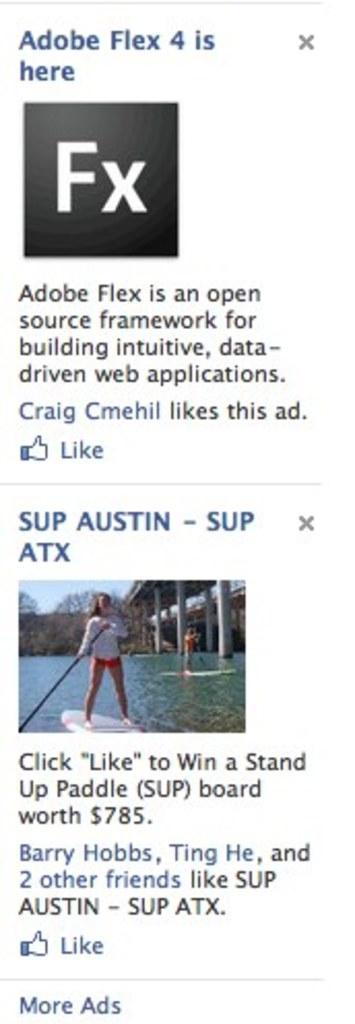How would you summarize this image in a sentence or two? In this image I can see a logo, text and a woman is boating in the water. In the background I can see poles, trees and the sky. This image is taken during a day. 